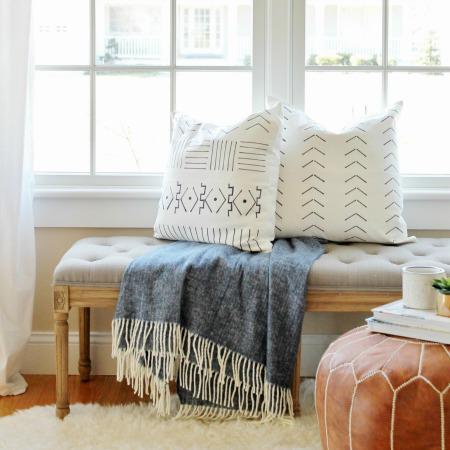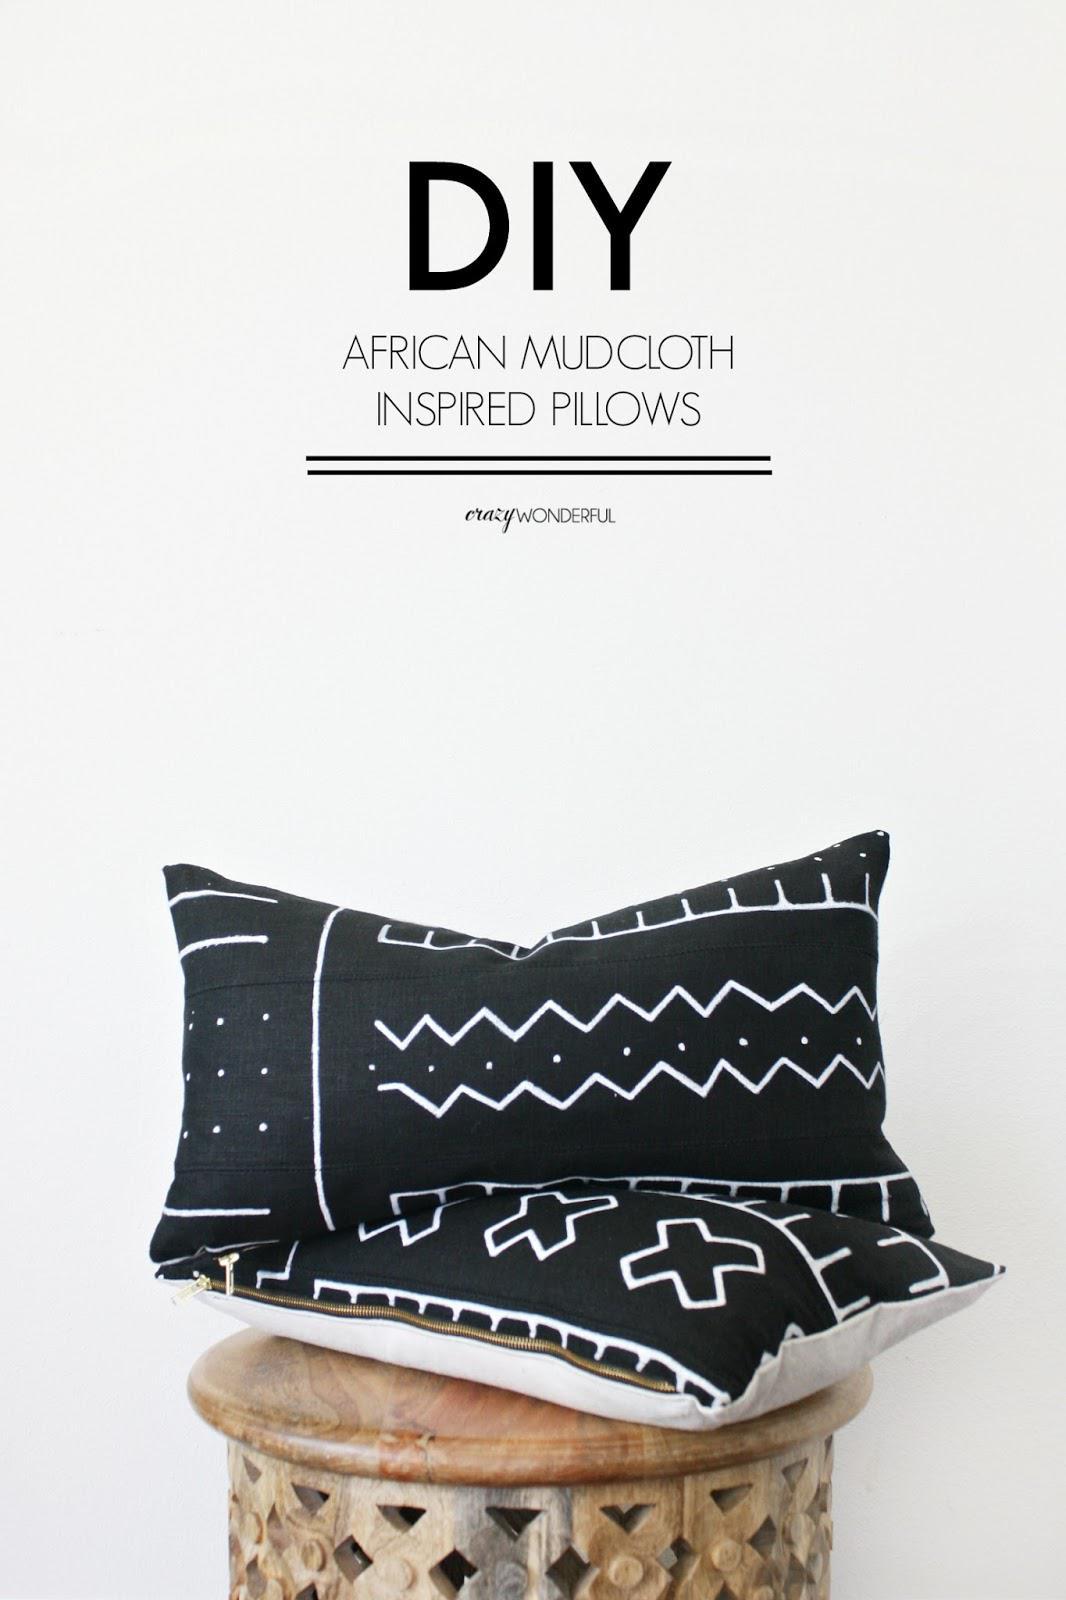The first image is the image on the left, the second image is the image on the right. Evaluate the accuracy of this statement regarding the images: "there is a bench in front of a window with a fringed blanket draped on it". Is it true? Answer yes or no. Yes. 